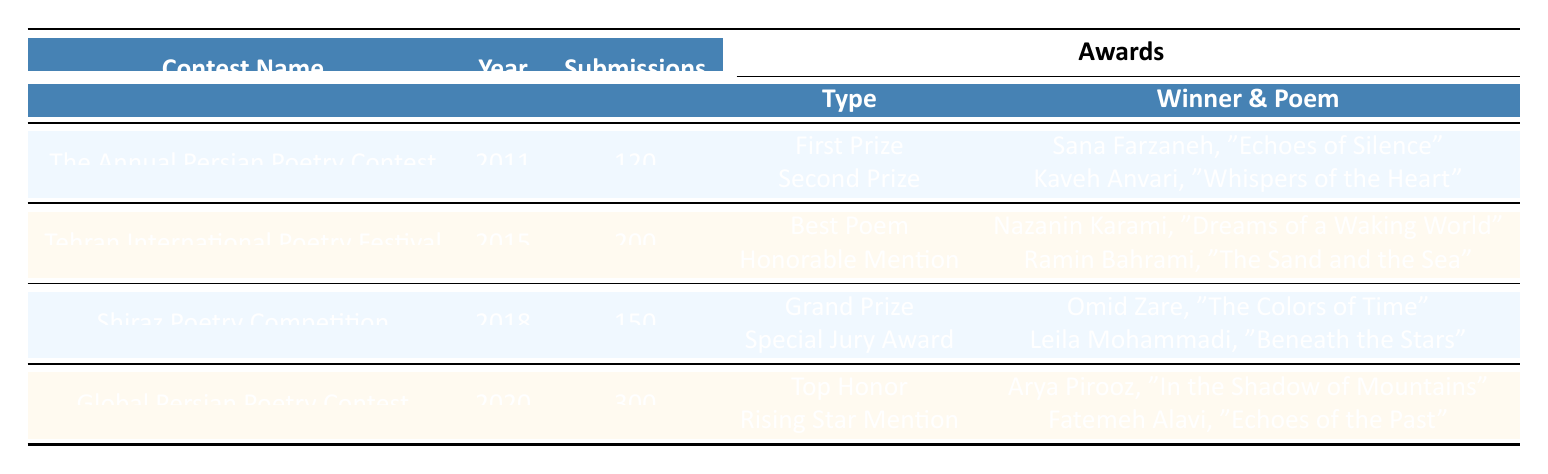What was the total number of submissions across all contests from 2010 to 2020? The submissions for each contest are as follows: 120 (2011) + 200 (2015) + 150 (2018) + 300 (2020) = 770.
Answer: 770 Who won the Grand Prize in the Shiraz Poetry Competition? The table shows the awards for the Shiraz Poetry Competition, where the Grand Prize was awarded to Omid Zare for the poem "The Colors of Time."
Answer: Omid Zare Which contest had the highest number of submissions? The Global Persian Poetry Contest in 2020 had 300 submissions, which is higher than any other contest listed.
Answer: Global Persian Poetry Contest Did any winners from the contests receive multiple awards in a single year? Each contest lists separate winners for different awards, and there are no instances of a winner being listed more than once in the same contest year.
Answer: No What award did Kaveh Anvari win and for which poem? The table indicates that Kaveh Anvari won the Second Prize for the poem "Whispers of the Heart" in The Annual Persian Poetry Contest.
Answer: Second Prize, "Whispers of the Heart" How many awards were given in total across all contests? Counting the awards provided: 2 (2011) + 2 (2015) + 2 (2018) + 2 (2020) = 8 awards in total.
Answer: 8 Which year had the most contests and how many submissions did it have? The table provides data for four separate contest years (2011, 2015, 2018, 2020), with each year showing only one contest; therefore, no year had multiple contests, and the maximum is for 2020 with 300 submissions.
Answer: 2020, 300 submissions What is the average number of submissions per contest from 2011 to 2020? Adding the total submissions (770) and dividing by the number of contests (4) gives an average of 770 / 4 = 192.5.
Answer: 192.5 Identify all winners from the Tehran International Poetry Festival and their respective poems. The table lists the winners as Nazanin Karami for "Dreams of a Waking World" and Ramin Bahrami for "The Sand and the Sea" under the awards for the Tehran International Poetry Festival.
Answer: Nazanin Karami, "Dreams of a Waking World"; Ramin Bahrami, "The Sand and the Sea" Which poem from the Global Persian Poetry Contest has a winner noted for 'Rising Star Mention'? The table indicates that Fatemeh Alavi won the Rising Star Mention for the poem "Echoes of the Past."
Answer: "Echoes of the Past" 